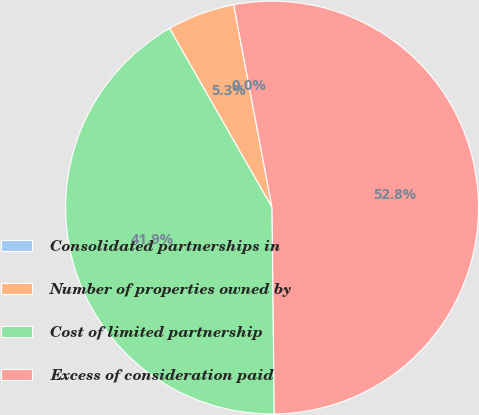Convert chart. <chart><loc_0><loc_0><loc_500><loc_500><pie_chart><fcel>Consolidated partnerships in<fcel>Number of properties owned by<fcel>Cost of limited partnership<fcel>Excess of consideration paid<nl><fcel>0.01%<fcel>5.29%<fcel>41.9%<fcel>52.81%<nl></chart> 